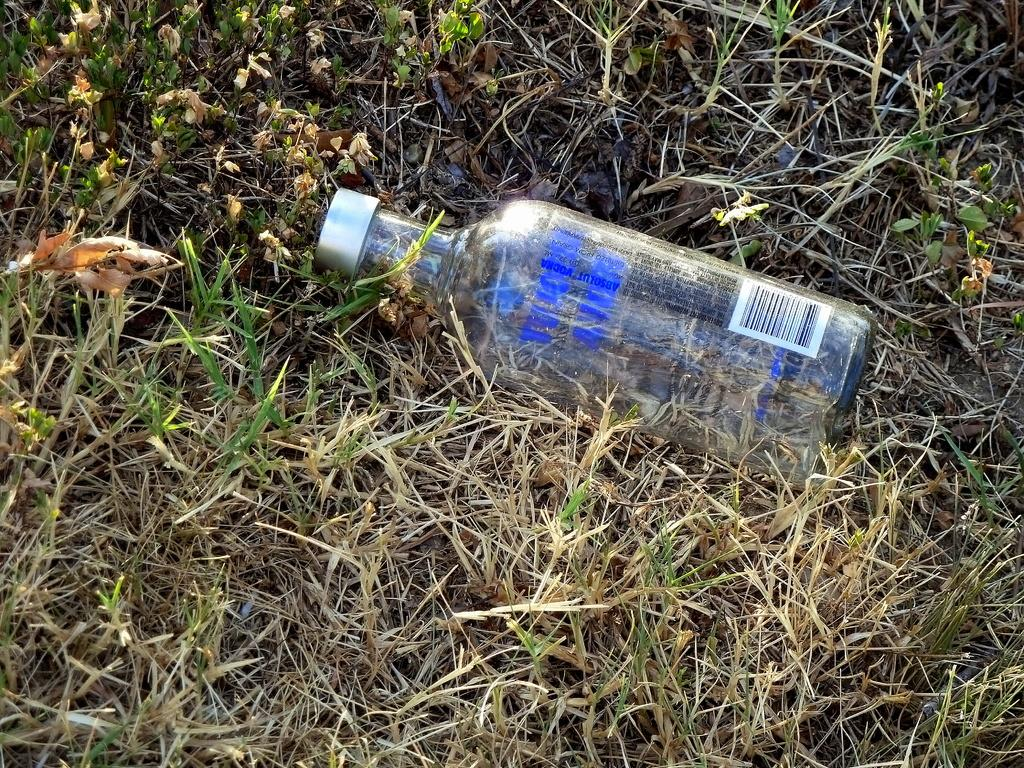What object can be seen in the image? There is a bottle in the image. Where is the bottle located? The bottle is on the grass. How much debt does the bottle owe in the image? There is no indication of debt in the image, as it features a bottle on the grass. What type of cake is being served by the bottle in the image? There is no cake present in the image, and the bottle is not serving anything. 